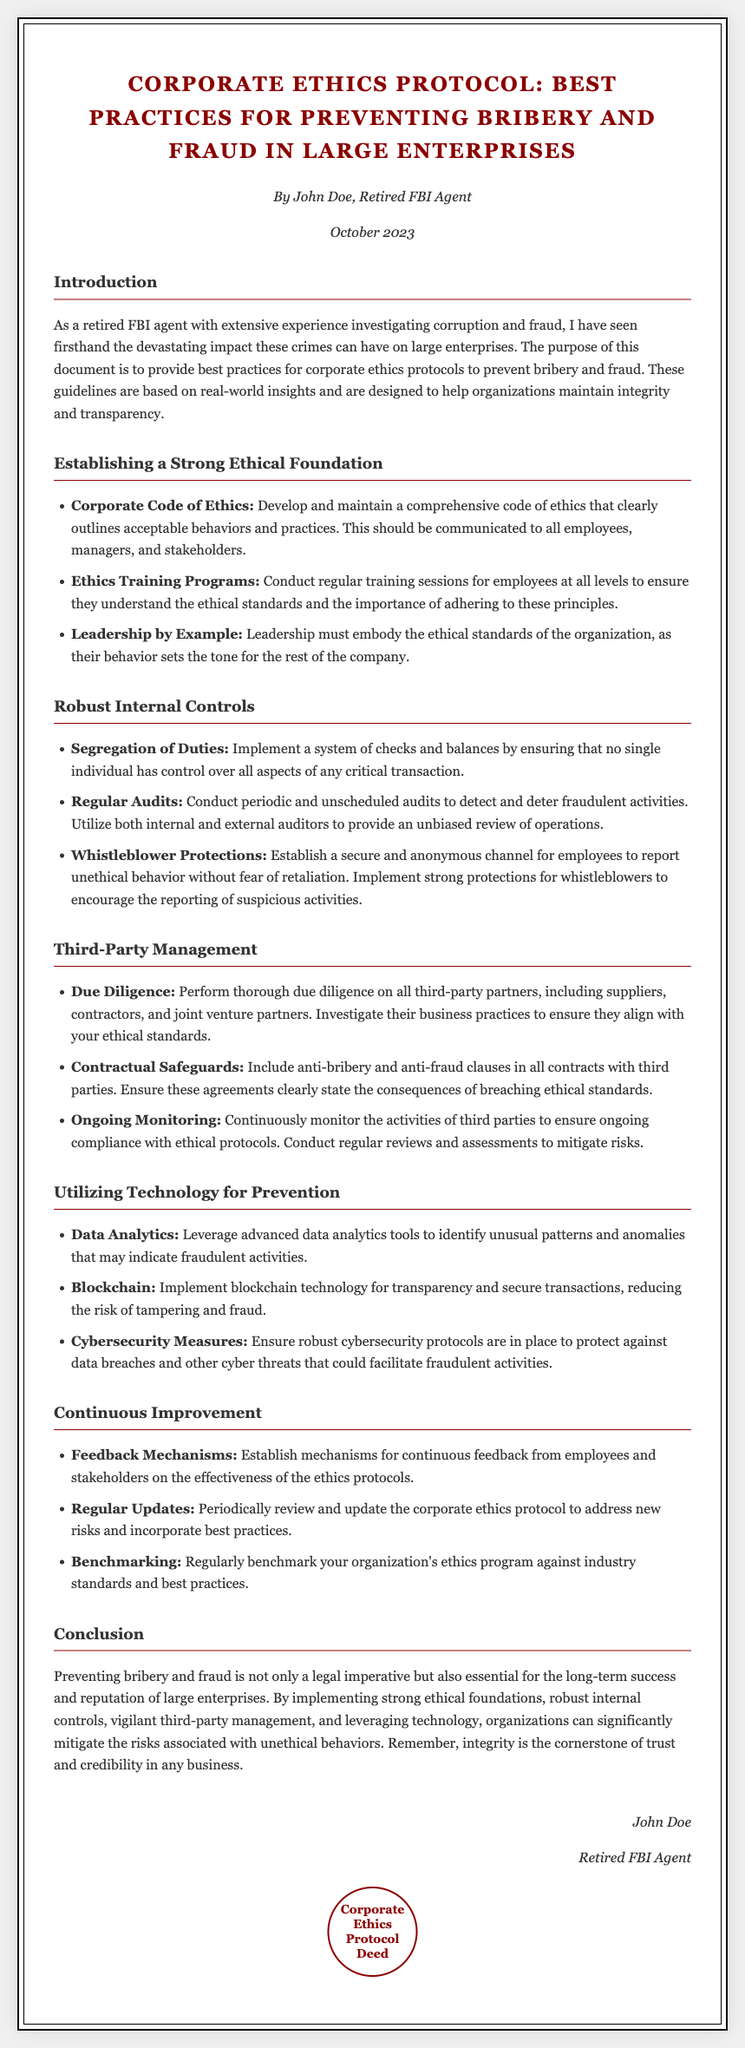What is the title of the document? The title is prominently displayed at the top of the document and refers to the main focus.
Answer: Corporate Ethics Protocol: Best Practices for Preventing Bribery and Fraud in Large Enterprises Who authored the document? The author’s name is mentioned in the meta section which identifies the credibility behind the guidelines.
Answer: John Doe What date was the document published? The publication date is included in the meta section, indicating when the document was created.
Answer: October 2023 What is the first section of the document? The sections are clearly numbered and named, with the first section introducing the purpose of the document.
Answer: Introduction What is one of the practices for establishing an ethical foundation? The document lists key practices under various sections; one practice specifically addresses ethics training.
Answer: Ethics Training Programs What kind of protection is recommended for whistleblowers? The document outlines specific measures to protect those who report unethical behavior.
Answer: Whistleblower Protections What technology is suggested for enhancing prevention efforts? Technology plays a significant role in the document, and it mentions a specific tool to identify fraudulent activities.
Answer: Data Analytics Why is continuous improvement emphasized in the document? The conclusion provides insights into the rationale behind maintaining and updating ethical practices.
Answer: To address new risks and incorporate best practices What is the main purpose of this document? The overarching goal of the document is articulated in the introduction.
Answer: To provide best practices for corporate ethics protocols to prevent bribery and fraud 